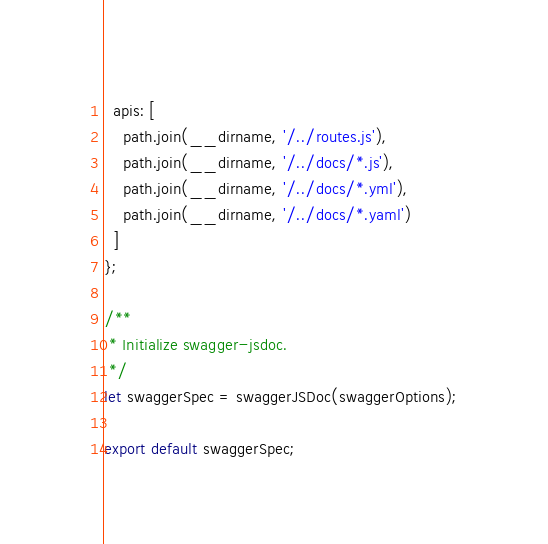Convert code to text. <code><loc_0><loc_0><loc_500><loc_500><_JavaScript_>  apis: [
    path.join(__dirname, '/../routes.js'),
    path.join(__dirname, '/../docs/*.js'),
    path.join(__dirname, '/../docs/*.yml'),
    path.join(__dirname, '/../docs/*.yaml')
  ]
};

/**
 * Initialize swagger-jsdoc.
 */
let swaggerSpec = swaggerJSDoc(swaggerOptions);

export default swaggerSpec;
</code> 